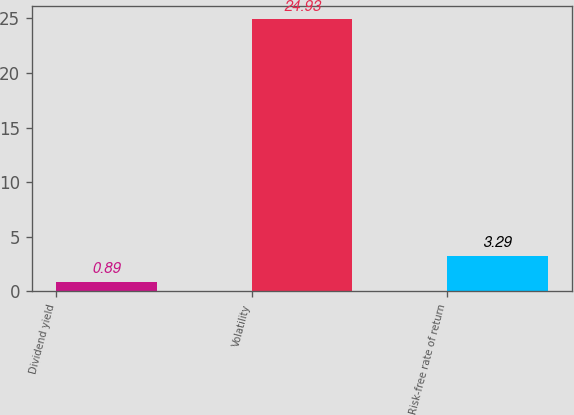<chart> <loc_0><loc_0><loc_500><loc_500><bar_chart><fcel>Dividend yield<fcel>Volatility<fcel>Risk-free rate of return<nl><fcel>0.89<fcel>24.93<fcel>3.29<nl></chart> 